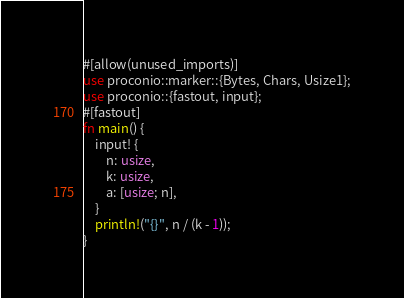Convert code to text. <code><loc_0><loc_0><loc_500><loc_500><_Rust_>#[allow(unused_imports)]
use proconio::marker::{Bytes, Chars, Usize1};
use proconio::{fastout, input};
#[fastout]
fn main() {
    input! {
        n: usize,
        k: usize,
        a: [usize; n],
    }
    println!("{}", n / (k - 1));
}
</code> 